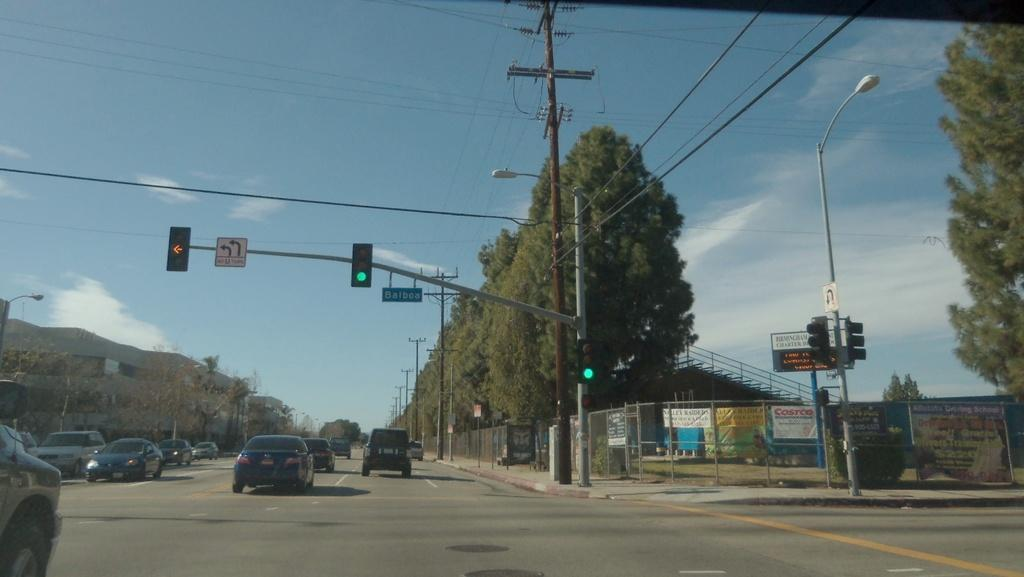<image>
Share a concise interpretation of the image provided. The sign attached to the traffic light pole indicates that U-turns are not allowed at this intersection. 